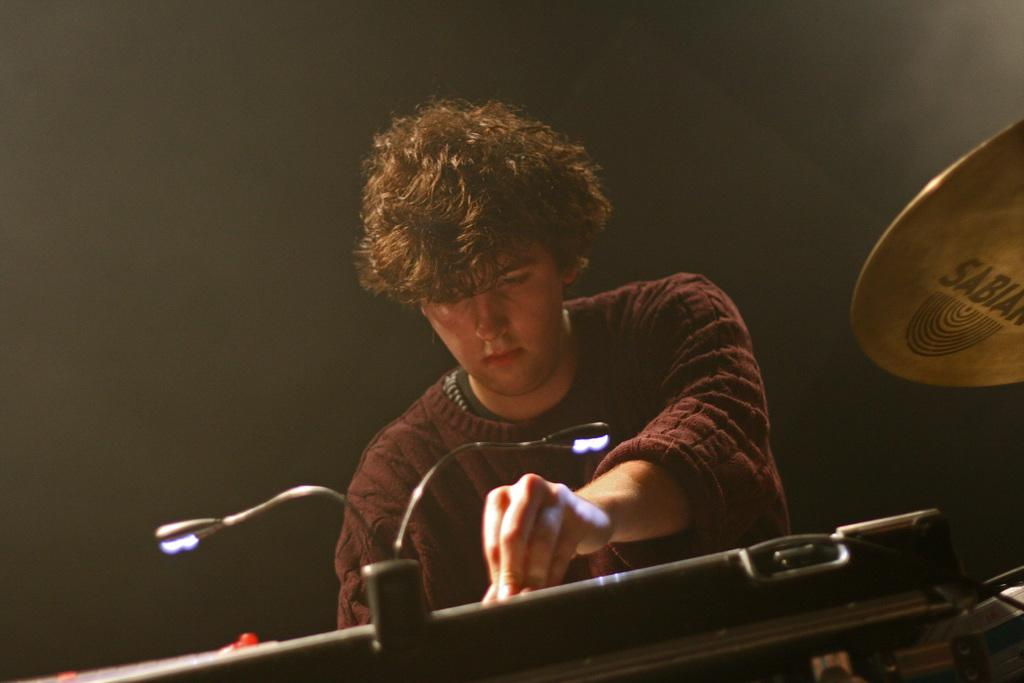Who or what is the main subject in the center of the image? There is a person in the center of the image. What else can be seen in the image besides the person? There are musical instruments in the image. What type of argument is taking place between the person and the musical instruments in the image? There is no argument present in the image; it only features a person and musical instruments. 